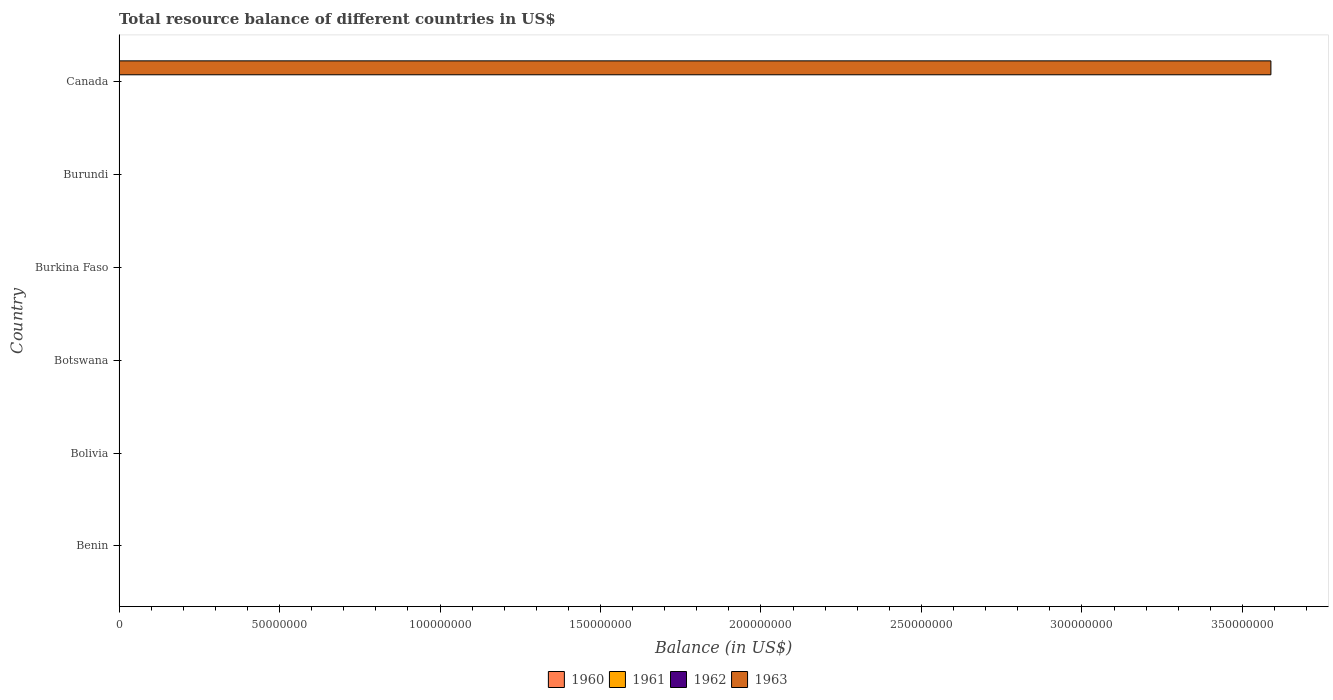How many different coloured bars are there?
Offer a very short reply. 1. How many bars are there on the 6th tick from the top?
Ensure brevity in your answer.  0. What is the label of the 5th group of bars from the top?
Give a very brief answer. Bolivia. What is the total resource balance in 1962 in Botswana?
Ensure brevity in your answer.  0. Across all countries, what is the maximum total resource balance in 1963?
Your answer should be compact. 3.59e+08. Across all countries, what is the minimum total resource balance in 1963?
Your answer should be compact. 0. What is the average total resource balance in 1962 per country?
Your answer should be very brief. 0. What is the difference between the highest and the lowest total resource balance in 1963?
Keep it short and to the point. 3.59e+08. In how many countries, is the total resource balance in 1961 greater than the average total resource balance in 1961 taken over all countries?
Keep it short and to the point. 0. Does the graph contain grids?
Provide a succinct answer. No. How many legend labels are there?
Provide a short and direct response. 4. What is the title of the graph?
Ensure brevity in your answer.  Total resource balance of different countries in US$. What is the label or title of the X-axis?
Provide a succinct answer. Balance (in US$). What is the label or title of the Y-axis?
Offer a terse response. Country. What is the Balance (in US$) in 1960 in Benin?
Offer a very short reply. 0. What is the Balance (in US$) in 1960 in Bolivia?
Your answer should be compact. 0. What is the Balance (in US$) in 1962 in Bolivia?
Give a very brief answer. 0. What is the Balance (in US$) in 1960 in Botswana?
Ensure brevity in your answer.  0. What is the Balance (in US$) in 1962 in Botswana?
Provide a succinct answer. 0. What is the Balance (in US$) in 1961 in Burkina Faso?
Make the answer very short. 0. What is the Balance (in US$) of 1963 in Burkina Faso?
Your response must be concise. 0. What is the Balance (in US$) in 1962 in Burundi?
Give a very brief answer. 0. What is the Balance (in US$) of 1963 in Burundi?
Your answer should be very brief. 0. What is the Balance (in US$) of 1961 in Canada?
Your response must be concise. 0. What is the Balance (in US$) in 1962 in Canada?
Make the answer very short. 0. What is the Balance (in US$) of 1963 in Canada?
Give a very brief answer. 3.59e+08. Across all countries, what is the maximum Balance (in US$) of 1963?
Give a very brief answer. 3.59e+08. What is the total Balance (in US$) in 1963 in the graph?
Provide a succinct answer. 3.59e+08. What is the average Balance (in US$) of 1962 per country?
Offer a terse response. 0. What is the average Balance (in US$) in 1963 per country?
Offer a terse response. 5.98e+07. What is the difference between the highest and the lowest Balance (in US$) of 1963?
Give a very brief answer. 3.59e+08. 